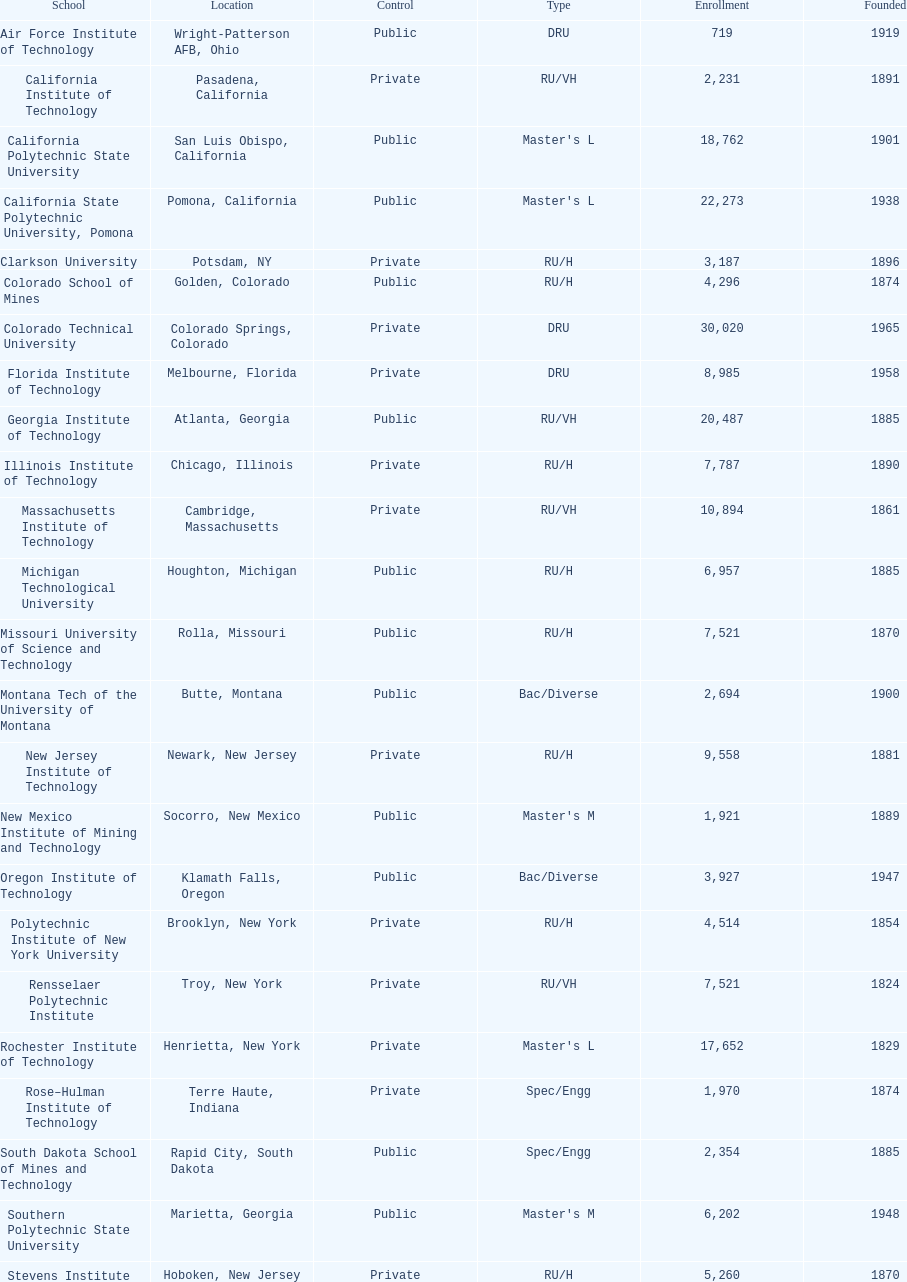How many technological institutions are there in california, usa? 3. 